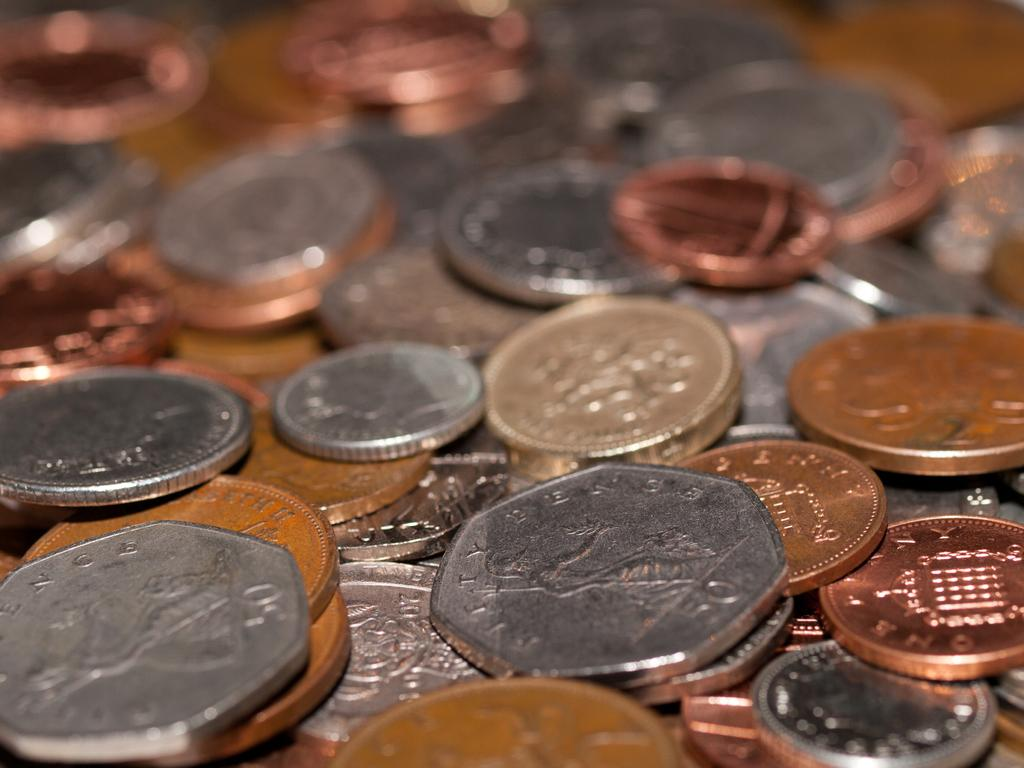What is located in the foreground of the image? There are currency coins in the foreground of the image. What is the coins placed on? The coins are placed on an object. Can you describe the background of the image? The background of the image is blurry. What type of stamp can be seen on the coins in the image? There is no stamp visible on the coins in the image. What details can be observed on the coins in the image? The provided facts do not mention any specific details on the coins, so we cannot answer this question definitively. 